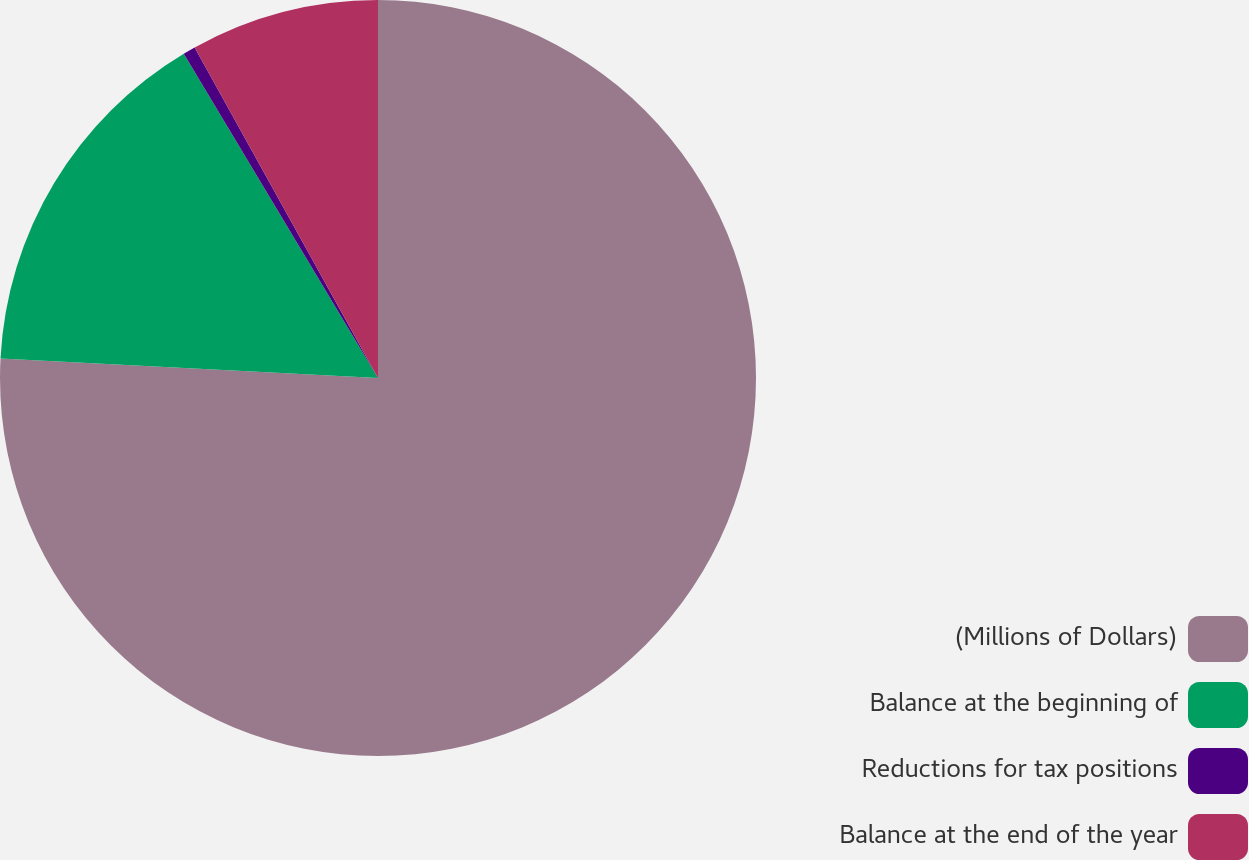<chart> <loc_0><loc_0><loc_500><loc_500><pie_chart><fcel>(Millions of Dollars)<fcel>Balance at the beginning of<fcel>Reductions for tax positions<fcel>Balance at the end of the year<nl><fcel>75.83%<fcel>15.59%<fcel>0.53%<fcel>8.06%<nl></chart> 